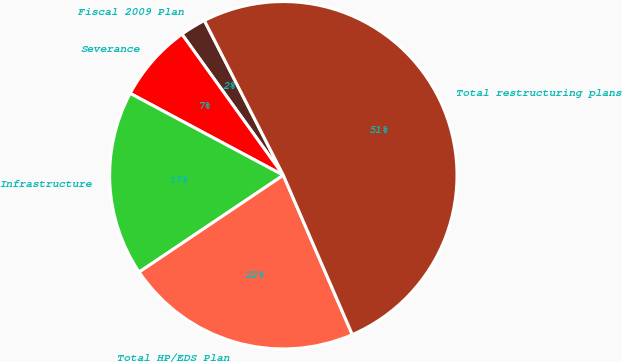Convert chart to OTSL. <chart><loc_0><loc_0><loc_500><loc_500><pie_chart><fcel>Fiscal 2009 Plan<fcel>Severance<fcel>Infrastructure<fcel>Total HP/EDS Plan<fcel>Total restructuring plans<nl><fcel>2.41%<fcel>7.27%<fcel>17.23%<fcel>22.09%<fcel>51.01%<nl></chart> 